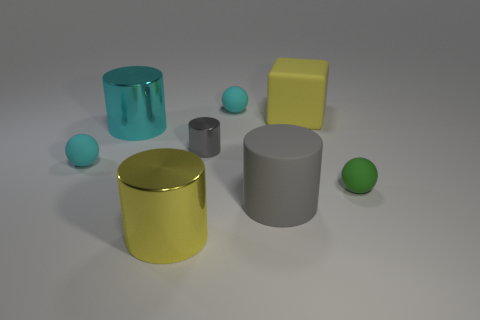How big is the object that is behind the tiny gray cylinder and left of the big yellow metal thing?
Your answer should be very brief. Large. What shape is the yellow matte thing that is the same size as the cyan cylinder?
Offer a very short reply. Cube. What color is the big rubber object that is the same shape as the small gray thing?
Provide a short and direct response. Gray. Does the big matte thing left of the yellow matte block have the same color as the small cylinder?
Make the answer very short. Yes. There is a small object that is behind the large yellow thing behind the rubber thing that is on the right side of the yellow rubber block; what is it made of?
Provide a short and direct response. Rubber. What number of spheres are left of the cyan rubber object behind the cyan sphere that is in front of the tiny metallic thing?
Your answer should be very brief. 1. There is a small thing that is the same color as the big rubber cylinder; what is its material?
Provide a short and direct response. Metal. Is the yellow metallic thing the same size as the rubber cylinder?
Keep it short and to the point. Yes. The gray metallic thing that is left of the gray object in front of the tiny cyan ball left of the cyan cylinder is what shape?
Offer a terse response. Cylinder. Is the material of the small cyan object to the right of the yellow metal cylinder the same as the yellow object in front of the big yellow block?
Keep it short and to the point. No. 